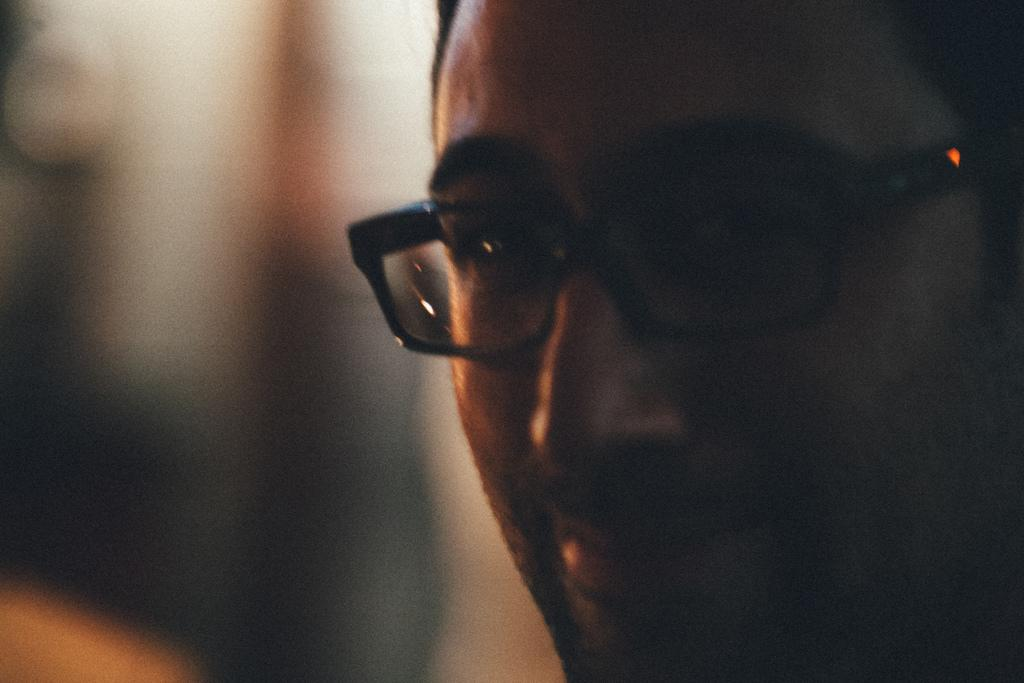What is the main subject in the foreground of the image? There is a person in the foreground of the image. Can you describe the person's appearance? The person is wearing spectacles. What can be observed about the background of the image? The background of the image is blurred. How is the glue being distributed in the image? There is no glue present in the image. 